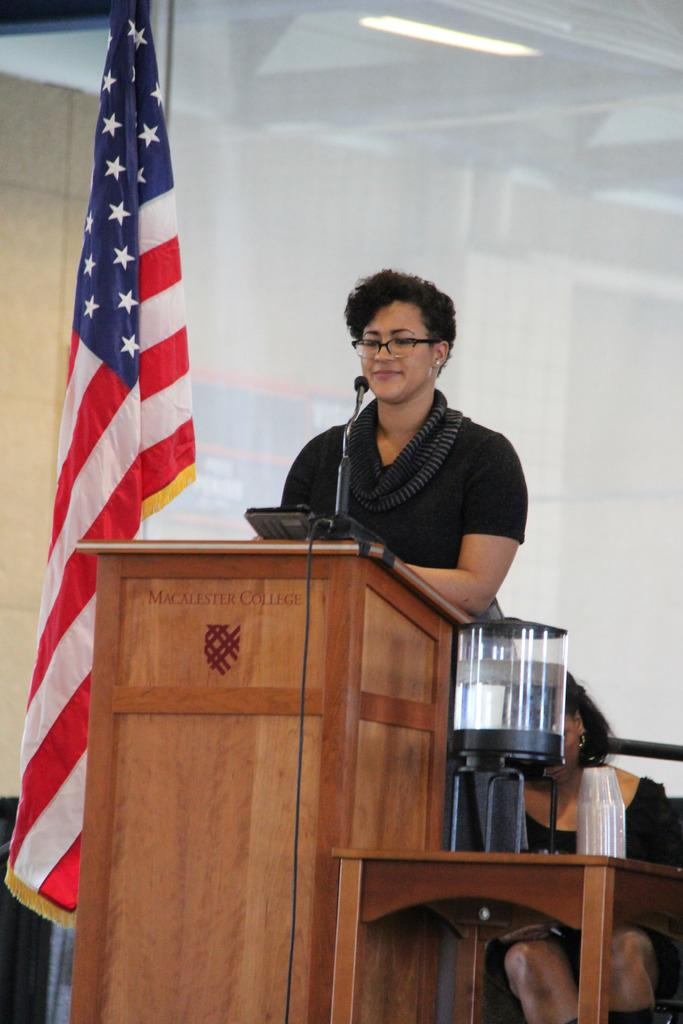<image>
Render a clear and concise summary of the photo. A speaker presents at a podium labeled Macalester College. 